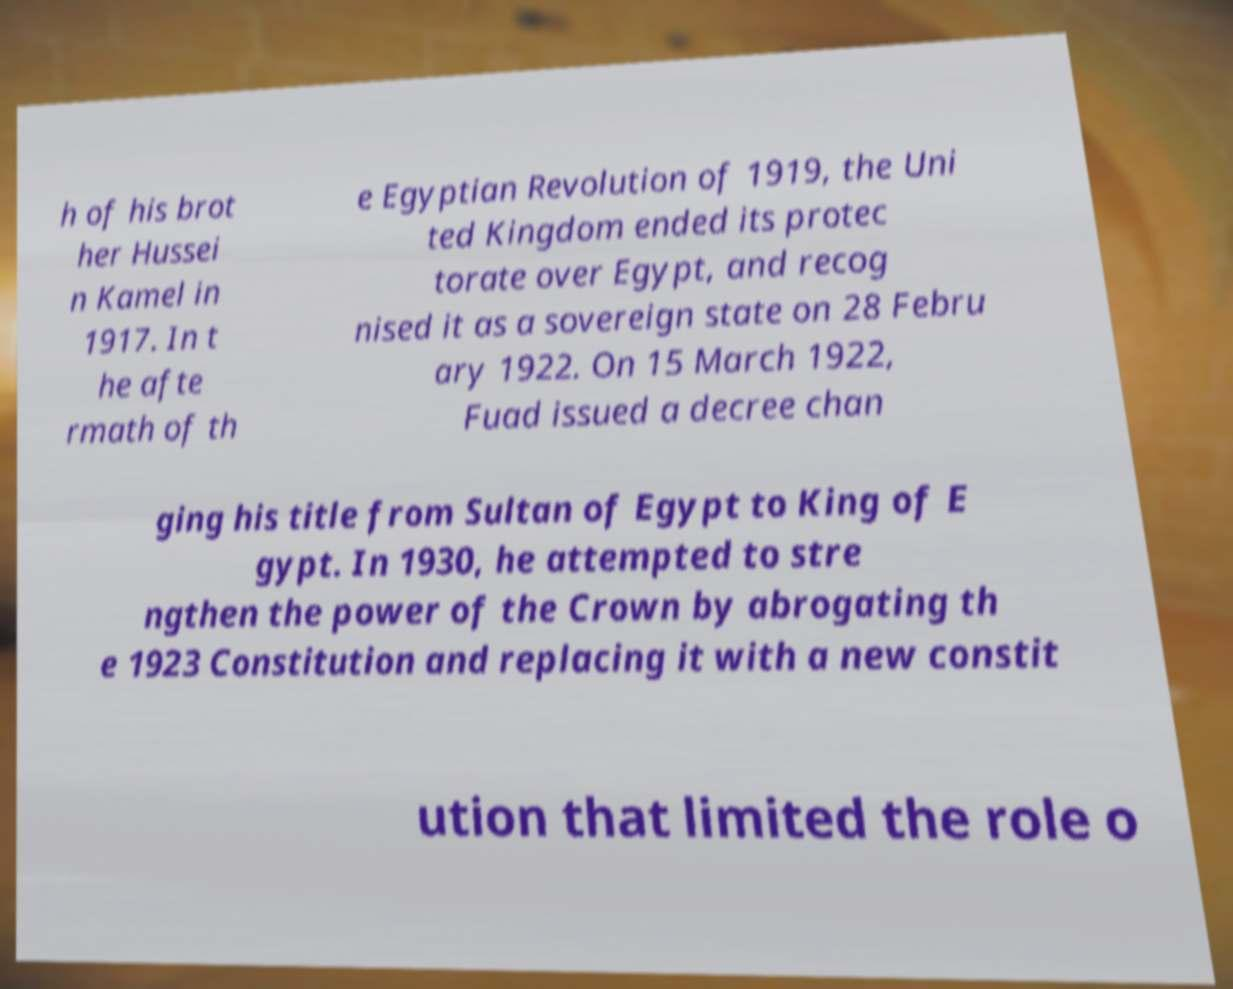Please identify and transcribe the text found in this image. h of his brot her Hussei n Kamel in 1917. In t he afte rmath of th e Egyptian Revolution of 1919, the Uni ted Kingdom ended its protec torate over Egypt, and recog nised it as a sovereign state on 28 Febru ary 1922. On 15 March 1922, Fuad issued a decree chan ging his title from Sultan of Egypt to King of E gypt. In 1930, he attempted to stre ngthen the power of the Crown by abrogating th e 1923 Constitution and replacing it with a new constit ution that limited the role o 